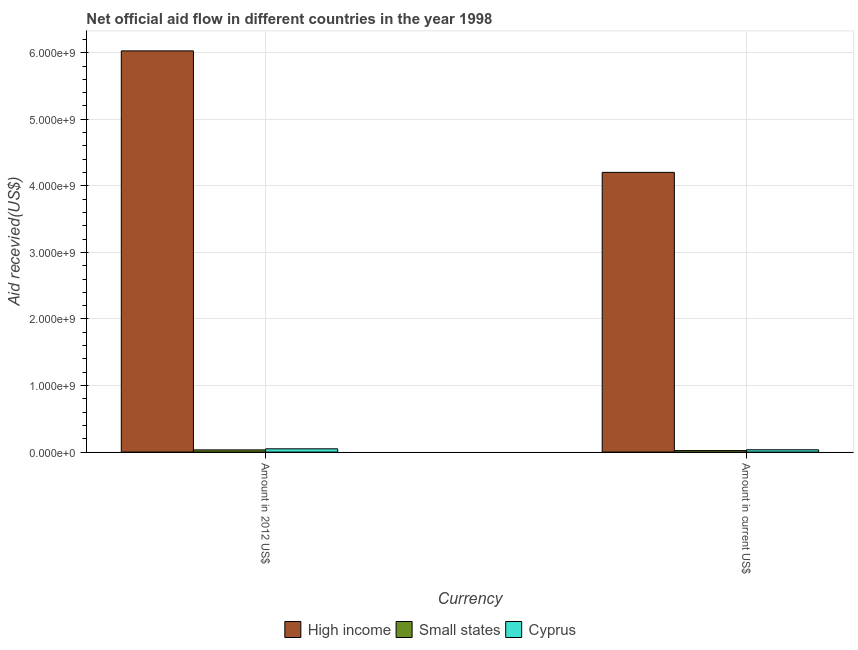How many different coloured bars are there?
Ensure brevity in your answer.  3. Are the number of bars per tick equal to the number of legend labels?
Your answer should be compact. Yes. How many bars are there on the 2nd tick from the left?
Offer a very short reply. 3. How many bars are there on the 2nd tick from the right?
Your response must be concise. 3. What is the label of the 1st group of bars from the left?
Offer a very short reply. Amount in 2012 US$. What is the amount of aid received(expressed in 2012 us$) in Small states?
Offer a very short reply. 3.29e+07. Across all countries, what is the maximum amount of aid received(expressed in 2012 us$)?
Make the answer very short. 6.03e+09. Across all countries, what is the minimum amount of aid received(expressed in 2012 us$)?
Provide a succinct answer. 3.29e+07. In which country was the amount of aid received(expressed in 2012 us$) maximum?
Provide a short and direct response. High income. In which country was the amount of aid received(expressed in 2012 us$) minimum?
Provide a succinct answer. Small states. What is the total amount of aid received(expressed in us$) in the graph?
Your answer should be very brief. 4.26e+09. What is the difference between the amount of aid received(expressed in 2012 us$) in Small states and that in Cyprus?
Your answer should be compact. -1.62e+07. What is the difference between the amount of aid received(expressed in us$) in Small states and the amount of aid received(expressed in 2012 us$) in High income?
Offer a very short reply. -6.00e+09. What is the average amount of aid received(expressed in 2012 us$) per country?
Ensure brevity in your answer.  2.04e+09. What is the difference between the amount of aid received(expressed in 2012 us$) and amount of aid received(expressed in us$) in High income?
Your answer should be compact. 1.83e+09. In how many countries, is the amount of aid received(expressed in 2012 us$) greater than 2800000000 US$?
Ensure brevity in your answer.  1. What is the ratio of the amount of aid received(expressed in 2012 us$) in Small states to that in High income?
Your answer should be compact. 0.01. Is the amount of aid received(expressed in 2012 us$) in High income less than that in Cyprus?
Your response must be concise. No. What does the 3rd bar from the left in Amount in current US$ represents?
Provide a short and direct response. Cyprus. What does the 2nd bar from the right in Amount in 2012 US$ represents?
Your answer should be very brief. Small states. How many bars are there?
Provide a succinct answer. 6. Are the values on the major ticks of Y-axis written in scientific E-notation?
Make the answer very short. Yes. Does the graph contain grids?
Ensure brevity in your answer.  Yes. Where does the legend appear in the graph?
Provide a short and direct response. Bottom center. How are the legend labels stacked?
Provide a succinct answer. Horizontal. What is the title of the graph?
Offer a terse response. Net official aid flow in different countries in the year 1998. What is the label or title of the X-axis?
Your answer should be compact. Currency. What is the label or title of the Y-axis?
Keep it short and to the point. Aid recevied(US$). What is the Aid recevied(US$) of High income in Amount in 2012 US$?
Make the answer very short. 6.03e+09. What is the Aid recevied(US$) of Small states in Amount in 2012 US$?
Your answer should be very brief. 3.29e+07. What is the Aid recevied(US$) of Cyprus in Amount in 2012 US$?
Offer a terse response. 4.91e+07. What is the Aid recevied(US$) of High income in Amount in current US$?
Your answer should be compact. 4.20e+09. What is the Aid recevied(US$) of Small states in Amount in current US$?
Your answer should be very brief. 2.26e+07. What is the Aid recevied(US$) of Cyprus in Amount in current US$?
Ensure brevity in your answer.  3.45e+07. Across all Currency, what is the maximum Aid recevied(US$) of High income?
Give a very brief answer. 6.03e+09. Across all Currency, what is the maximum Aid recevied(US$) of Small states?
Make the answer very short. 3.29e+07. Across all Currency, what is the maximum Aid recevied(US$) in Cyprus?
Provide a succinct answer. 4.91e+07. Across all Currency, what is the minimum Aid recevied(US$) of High income?
Offer a terse response. 4.20e+09. Across all Currency, what is the minimum Aid recevied(US$) of Small states?
Offer a terse response. 2.26e+07. Across all Currency, what is the minimum Aid recevied(US$) in Cyprus?
Your response must be concise. 3.45e+07. What is the total Aid recevied(US$) of High income in the graph?
Ensure brevity in your answer.  1.02e+1. What is the total Aid recevied(US$) of Small states in the graph?
Provide a short and direct response. 5.55e+07. What is the total Aid recevied(US$) of Cyprus in the graph?
Your answer should be compact. 8.36e+07. What is the difference between the Aid recevied(US$) of High income in Amount in 2012 US$ and that in Amount in current US$?
Keep it short and to the point. 1.83e+09. What is the difference between the Aid recevied(US$) in Small states in Amount in 2012 US$ and that in Amount in current US$?
Your answer should be very brief. 1.03e+07. What is the difference between the Aid recevied(US$) in Cyprus in Amount in 2012 US$ and that in Amount in current US$?
Give a very brief answer. 1.46e+07. What is the difference between the Aid recevied(US$) in High income in Amount in 2012 US$ and the Aid recevied(US$) in Small states in Amount in current US$?
Offer a terse response. 6.00e+09. What is the difference between the Aid recevied(US$) of High income in Amount in 2012 US$ and the Aid recevied(US$) of Cyprus in Amount in current US$?
Give a very brief answer. 5.99e+09. What is the difference between the Aid recevied(US$) of Small states in Amount in 2012 US$ and the Aid recevied(US$) of Cyprus in Amount in current US$?
Offer a very short reply. -1.63e+06. What is the average Aid recevied(US$) of High income per Currency?
Your answer should be very brief. 5.11e+09. What is the average Aid recevied(US$) in Small states per Currency?
Provide a succinct answer. 2.78e+07. What is the average Aid recevied(US$) of Cyprus per Currency?
Offer a terse response. 4.18e+07. What is the difference between the Aid recevied(US$) of High income and Aid recevied(US$) of Small states in Amount in 2012 US$?
Ensure brevity in your answer.  5.99e+09. What is the difference between the Aid recevied(US$) in High income and Aid recevied(US$) in Cyprus in Amount in 2012 US$?
Your answer should be very brief. 5.98e+09. What is the difference between the Aid recevied(US$) of Small states and Aid recevied(US$) of Cyprus in Amount in 2012 US$?
Your response must be concise. -1.62e+07. What is the difference between the Aid recevied(US$) of High income and Aid recevied(US$) of Small states in Amount in current US$?
Keep it short and to the point. 4.18e+09. What is the difference between the Aid recevied(US$) of High income and Aid recevied(US$) of Cyprus in Amount in current US$?
Offer a terse response. 4.17e+09. What is the difference between the Aid recevied(US$) of Small states and Aid recevied(US$) of Cyprus in Amount in current US$?
Provide a short and direct response. -1.19e+07. What is the ratio of the Aid recevied(US$) of High income in Amount in 2012 US$ to that in Amount in current US$?
Keep it short and to the point. 1.43. What is the ratio of the Aid recevied(US$) of Small states in Amount in 2012 US$ to that in Amount in current US$?
Offer a very short reply. 1.46. What is the ratio of the Aid recevied(US$) in Cyprus in Amount in 2012 US$ to that in Amount in current US$?
Offer a very short reply. 1.42. What is the difference between the highest and the second highest Aid recevied(US$) of High income?
Provide a short and direct response. 1.83e+09. What is the difference between the highest and the second highest Aid recevied(US$) of Small states?
Provide a succinct answer. 1.03e+07. What is the difference between the highest and the second highest Aid recevied(US$) of Cyprus?
Ensure brevity in your answer.  1.46e+07. What is the difference between the highest and the lowest Aid recevied(US$) of High income?
Your response must be concise. 1.83e+09. What is the difference between the highest and the lowest Aid recevied(US$) of Small states?
Provide a succinct answer. 1.03e+07. What is the difference between the highest and the lowest Aid recevied(US$) in Cyprus?
Offer a terse response. 1.46e+07. 